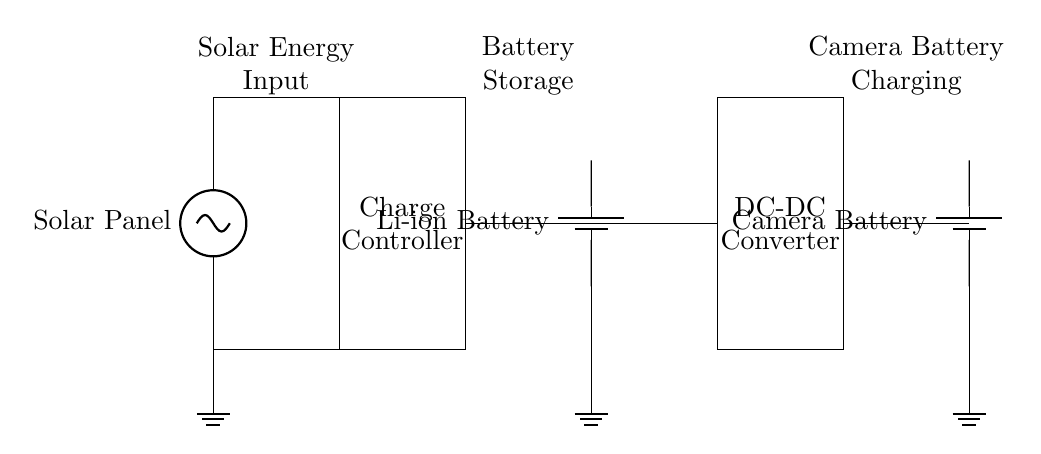What component converts solar energy? The component that converts solar energy is the solar panel, which transforms sunlight into electrical energy that can be used to charge batteries.
Answer: solar panel What is the role of the charge controller? The charge controller regulates the voltage and current coming from the solar panel to the battery, ensuring that the battery is charged properly and not overcharged.
Answer: regulates charging How many batteries are present in this circuit? The circuit contains two batteries: one for storage (Li-ion Battery) and one specifically for the camera (Camera Battery).
Answer: two batteries What type of battery is used for storage? The storage battery used in this circuit is a lithium-ion battery, which is commonly used due to its lightweight and high energy density.
Answer: Li-ion Battery What is the purpose of the DC-DC converter? The purpose of the DC-DC converter is to step up or step down the voltage from the stored battery to match the needs of the camera battery for charging.
Answer: voltage adjustment What is the direction of current flow from the solar panel to the camera battery? The current flows from the solar panel to the charge controller, then to the storage battery, passing through the DC-DC converter before reaching the camera battery.
Answer: from solar panel to camera battery What is the function of the ground symbols in the circuit? The ground symbols represent a common return path for the electrical current, providing a reference point for the voltage levels in the circuit, ensuring safety and stability.
Answer: reference point 